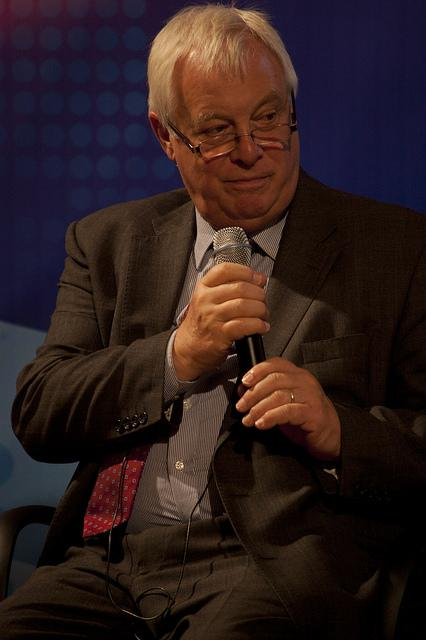What is he about to do? speak 